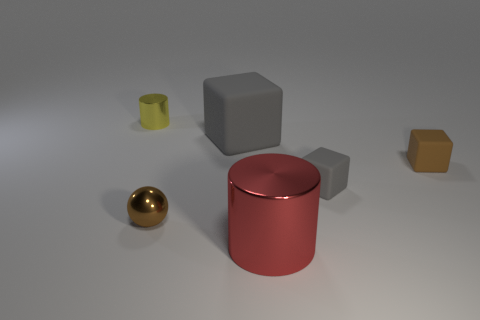Subtract all gray cubes. How many were subtracted if there are1gray cubes left? 1 Subtract all red spheres. How many gray blocks are left? 2 Subtract all gray cubes. How many cubes are left? 1 Add 1 small green shiny cubes. How many objects exist? 7 Add 4 balls. How many balls are left? 5 Add 3 red shiny things. How many red shiny things exist? 4 Subtract 0 purple cylinders. How many objects are left? 6 Subtract all cylinders. How many objects are left? 4 Subtract all blue rubber cubes. Subtract all cylinders. How many objects are left? 4 